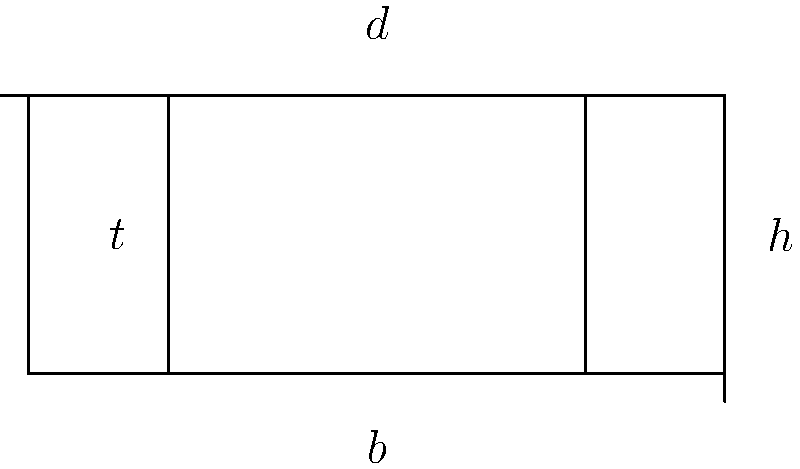Calculate the moment of inertia of the cross-section of a reinforced concrete beam shown in the figure. The outer dimensions of the beam are $b = 50$ cm and $h = 20$ cm, while the inner hollow section has dimensions $d = 30$ cm and $t = 10$ cm. Assume the beam is made of homogeneous material. To calculate the moment of inertia of this cross-section, we'll follow these steps:

1) First, calculate the moment of inertia of the entire rectangular section:
   $$I_1 = \frac{1}{12}bh^3 = \frac{1}{12} \cdot 50 \cdot 20^3 = 33,333.33 \text{ cm}^4$$

2) Then, calculate the moment of inertia of the hollow section:
   $$I_2 = \frac{1}{12}dt^3 = \frac{1}{12} \cdot 30 \cdot 10^3 = 2,500 \text{ cm}^4$$

3) The moment of inertia of the actual cross-section is the difference between these two:
   $$I = I_1 - I_2 = 33,333.33 - 2,500 = 30,833.33 \text{ cm}^4$$

4) Convert to m^4:
   $$I = 30,833.33 \cdot 10^{-8} = 0.00308333 \text{ m}^4$$

Therefore, the moment of inertia of the cross-section is approximately 0.00308 m^4.
Answer: 0.00308 m^4 